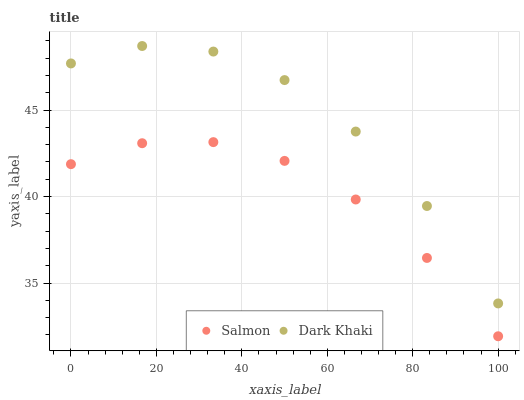Does Salmon have the minimum area under the curve?
Answer yes or no. Yes. Does Dark Khaki have the maximum area under the curve?
Answer yes or no. Yes. Does Salmon have the maximum area under the curve?
Answer yes or no. No. Is Salmon the smoothest?
Answer yes or no. Yes. Is Dark Khaki the roughest?
Answer yes or no. Yes. Is Salmon the roughest?
Answer yes or no. No. Does Salmon have the lowest value?
Answer yes or no. Yes. Does Dark Khaki have the highest value?
Answer yes or no. Yes. Does Salmon have the highest value?
Answer yes or no. No. Is Salmon less than Dark Khaki?
Answer yes or no. Yes. Is Dark Khaki greater than Salmon?
Answer yes or no. Yes. Does Salmon intersect Dark Khaki?
Answer yes or no. No. 